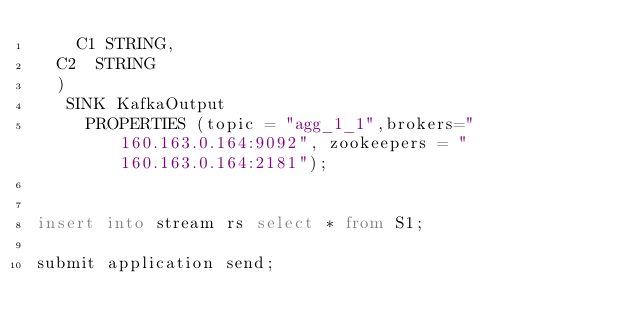Convert code to text. <code><loc_0><loc_0><loc_500><loc_500><_SQL_>    C1 STRING,
	C2  STRING
	)
	 SINK KafkaOutput
		 PROPERTIES (topic = "agg_1_1",brokers="160.163.0.164:9092", zookeepers = "160.163.0.164:2181");


insert into stream rs select * from S1;

submit application send;
</code> 